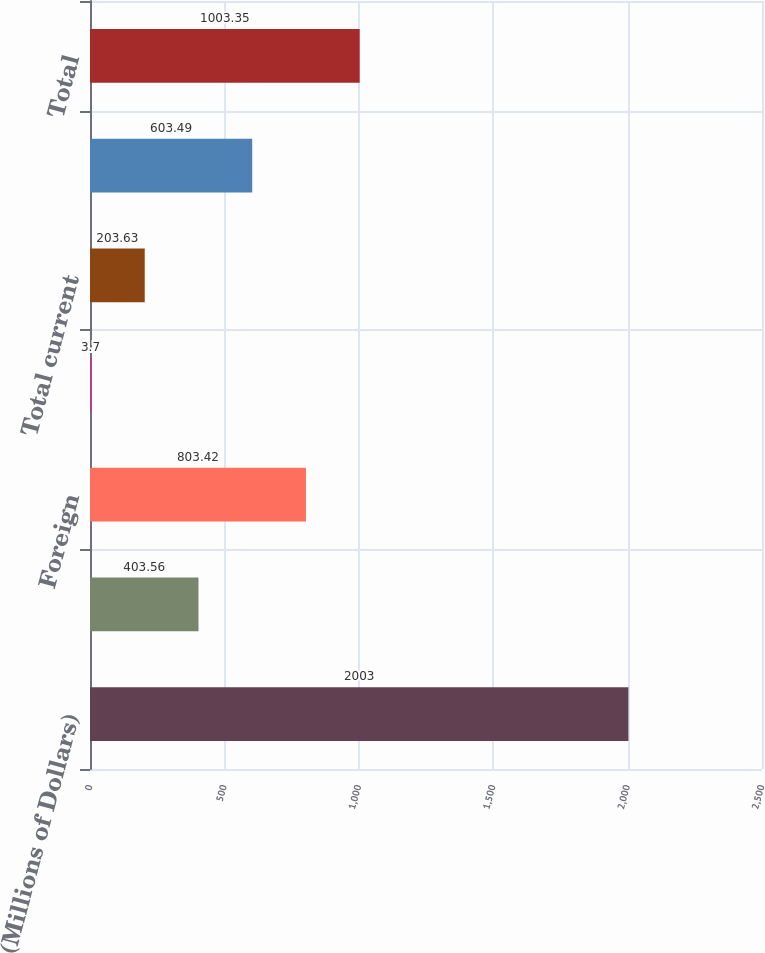Convert chart. <chart><loc_0><loc_0><loc_500><loc_500><bar_chart><fcel>(Millions of Dollars)<fcel>Federal<fcel>Foreign<fcel>State<fcel>Total current<fcel>Total deferred<fcel>Total<nl><fcel>2003<fcel>403.56<fcel>803.42<fcel>3.7<fcel>203.63<fcel>603.49<fcel>1003.35<nl></chart> 